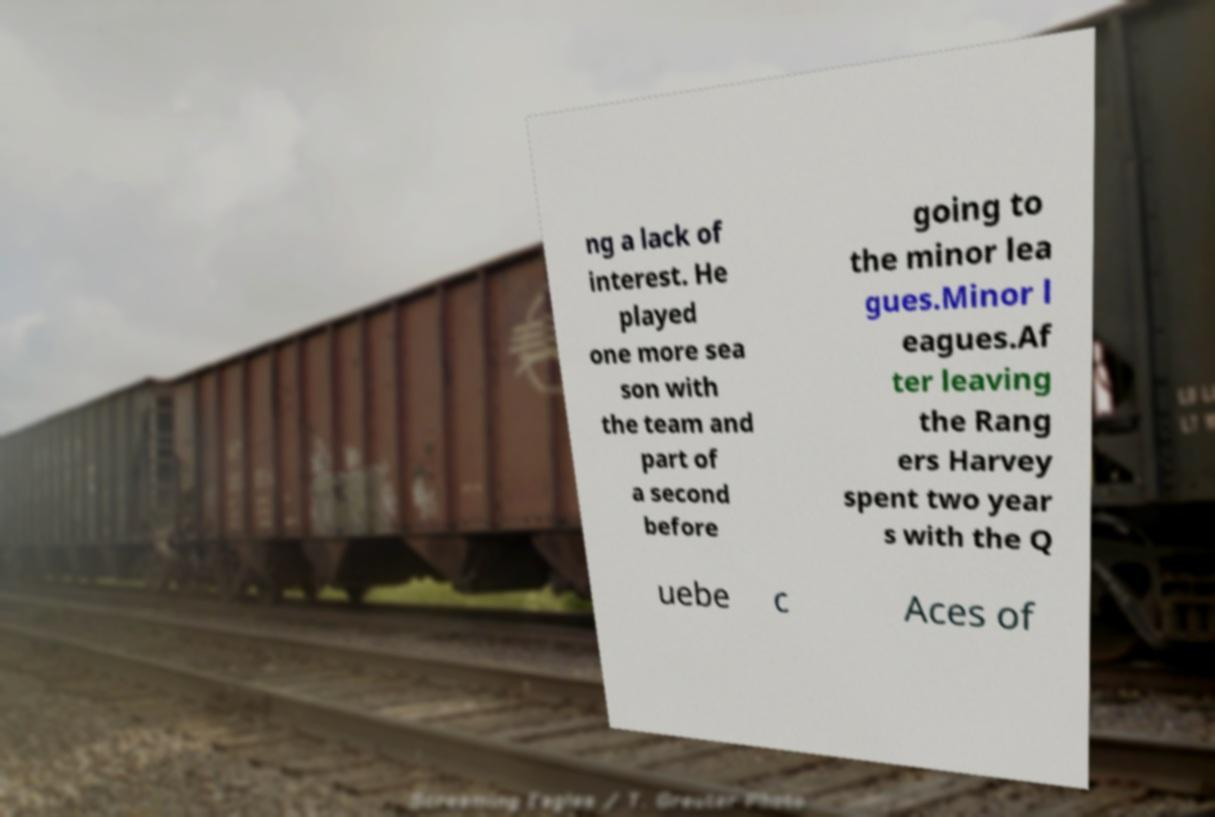I need the written content from this picture converted into text. Can you do that? ng a lack of interest. He played one more sea son with the team and part of a second before going to the minor lea gues.Minor l eagues.Af ter leaving the Rang ers Harvey spent two year s with the Q uebe c Aces of 